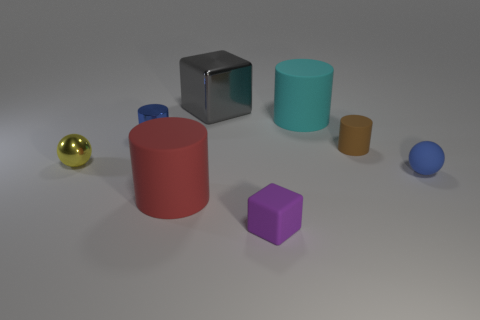What number of other rubber things have the same size as the red rubber thing?
Offer a terse response. 1. What is the color of the object that is right of the big metal block and in front of the blue matte thing?
Offer a very short reply. Purple. How many objects are either tiny blue metal objects or rubber spheres?
Offer a very short reply. 2. What number of large objects are either purple matte spheres or yellow metallic things?
Make the answer very short. 0. Is there anything else that has the same color as the rubber block?
Keep it short and to the point. No. What size is the object that is both behind the brown matte cylinder and on the left side of the big gray cube?
Ensure brevity in your answer.  Small. Is the color of the tiny object that is in front of the red cylinder the same as the ball behind the blue sphere?
Your answer should be compact. No. What number of other objects are there of the same material as the large red cylinder?
Offer a terse response. 4. There is a object that is both in front of the tiny blue matte ball and to the left of the big metal thing; what is its shape?
Provide a succinct answer. Cylinder. There is a shiny cylinder; does it have the same color as the big cylinder that is right of the small purple object?
Offer a very short reply. No. 